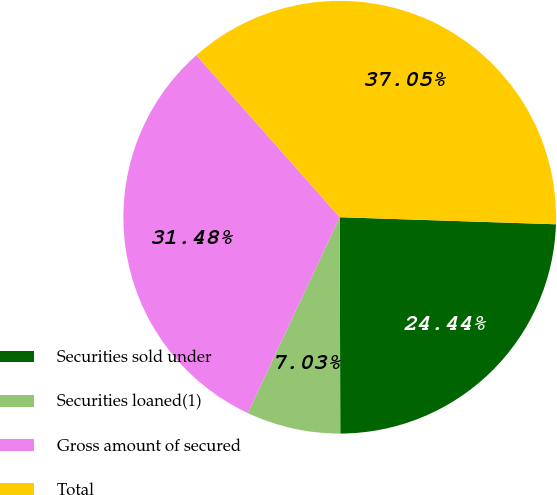Convert chart. <chart><loc_0><loc_0><loc_500><loc_500><pie_chart><fcel>Securities sold under<fcel>Securities loaned(1)<fcel>Gross amount of secured<fcel>Total<nl><fcel>24.44%<fcel>7.03%<fcel>31.48%<fcel>37.05%<nl></chart> 